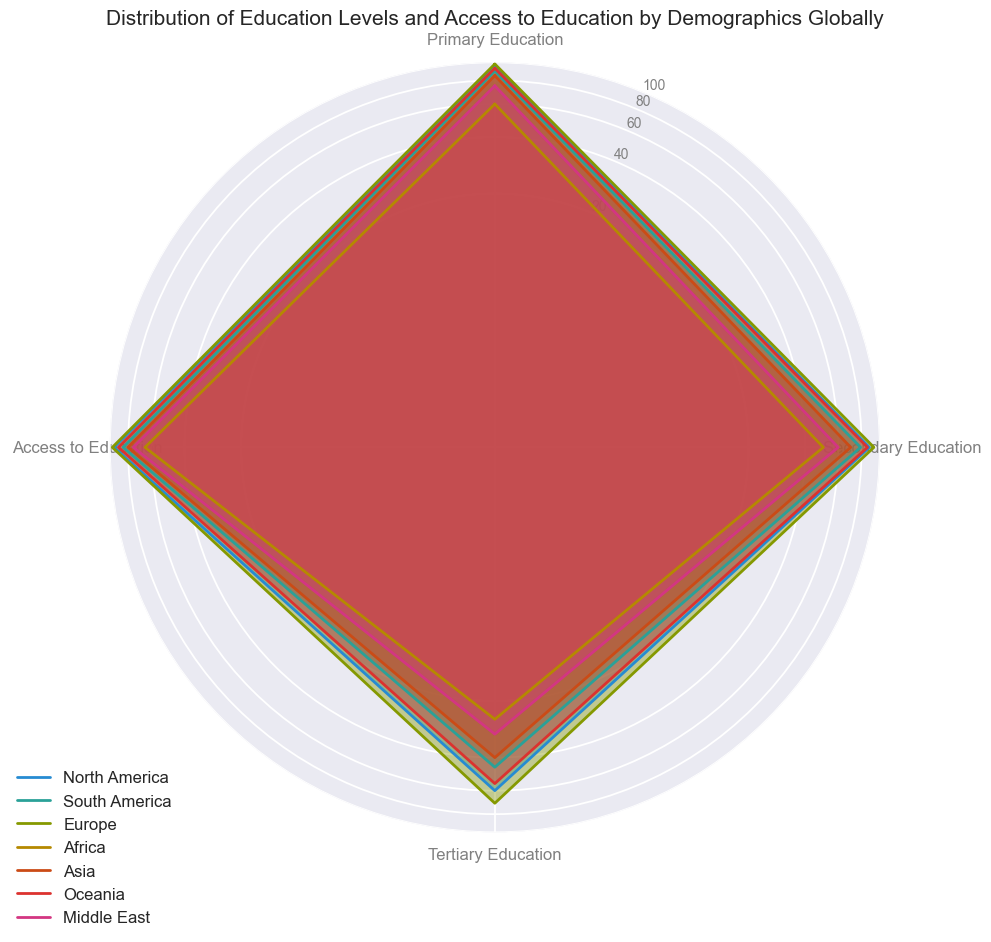What's the primary education level in Europe? The primary education level for Europe can be found on the radar chart by looking at the corresponding line for Europe and finding the point on the axis labeled "Primary Education." This value is given by the length of the line reaching up to the primary education axis.
Answer: 98 Which region has the lowest access to education? To find which region has the lowest access to education, look at the points corresponding to "Access to Education" on the radar chart and identify the region with the shortest line on this axis. The region with the shortest line on the "Access to Education" axis will have the lowest access to education.
Answer: Africa Compare the tertiary education level between North America and South America. Which region has a higher level? Find the points on the radar chart corresponding to "Tertiary Education" for North America and South America. Compare the lengths of the lines reaching up to the tertiary education axis for both regions to determine which one is higher.
Answer: North America What is the difference in secondary education levels between Europe and Asia? Find the values for secondary education levels for both Europe and Asia on the radar chart. Subtract the value for Asia from the value for Europe: 93 - 70.
Answer: 23 Which region has the highest value for access to education? Identify the point on the radar chart labeled "Access to Education" that has the longest line. The region corresponding to this point will have the highest value for access to education.
Answer: Europe Calculate the average tertiary education level for North America, South America, and Europe. Find the tertiary education levels for North America (60), South America (45), and Europe (70). Sum them up and divide by 3: (60 + 45 + 70) / 3.
Answer: 58.33 Is the primary education level in Africa higher or lower than the secondary education level in the Middle East? Find the values for primary education level in Africa (60) and secondary education level in the Middle East (60) on the radar chart. Compare these values.
Answer: Equal Compare the figure for access to education in Oceania with tertiary education in Asia. Which is higher? Find the values for access to education in Oceania (90) and tertiary education in Asia (40) on the radar chart. Compare these values.
Answer: Access to education in Oceania What is the combined percentage of primary and secondary education levels for South America? Find the values for primary education (90) and secondary education (79) levels for South America. Sum these values: 90 + 79.
Answer: 169 How does the secondary education level in Africa compare to the primary education level in Asia? Find the values for secondary education in Africa (50) and primary education in Asia (85) on the radar chart and compare these values.
Answer: Primary education in Asia is higher 